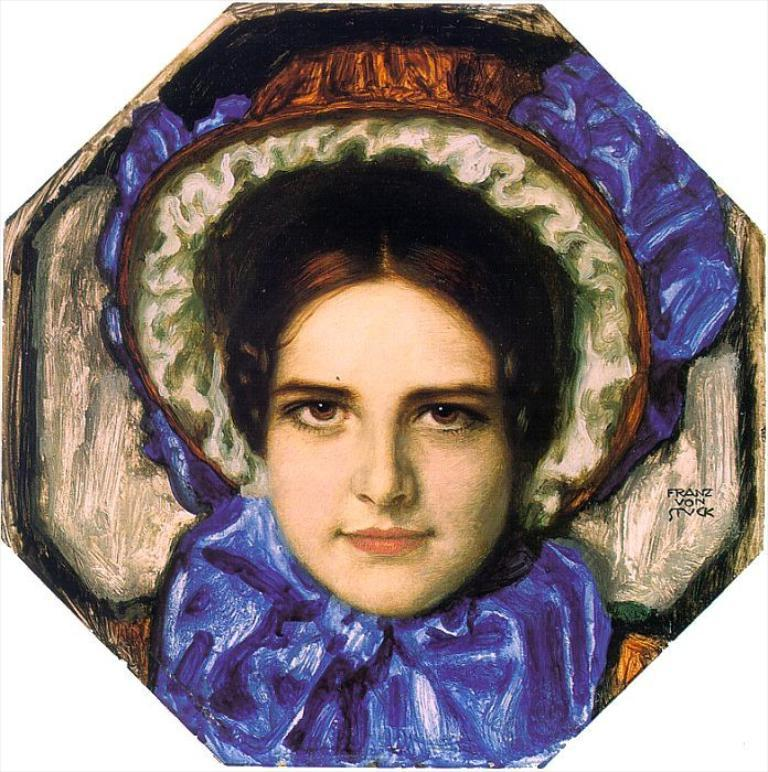What is depicted in the image? There is a painting of a woman in the image. Are there any additional elements on the painting? Yes, there are letters on the painting. Can you see a snail crawling on the painting in the image? No, there is no snail present on the painting in the image. 